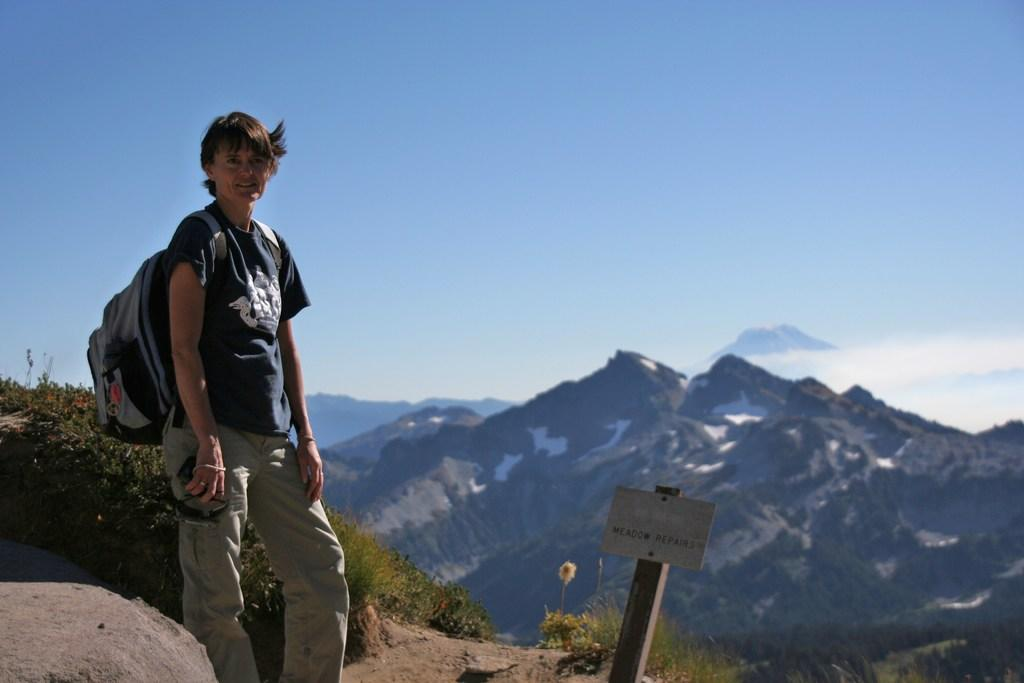What is the main subject of the image? There is a person standing in the image. What is the person wearing in the image? The person is wearing a bag. What can be seen in the background of the image? There are mountains and the sky visible in the background of the image. What object is present in the image? There is a board in the image. What direction is the person walking in the image? The image does not show the person walking; they are standing still. What songs can be heard playing in the background of the image? There is no audio or music present in the image, so it is not possible to determine what songs might be heard. 